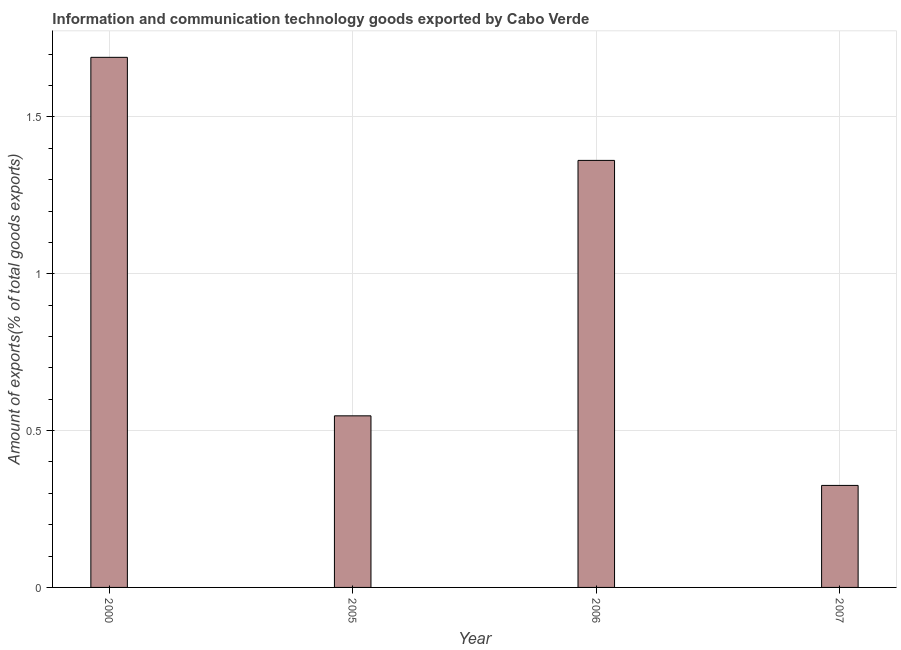What is the title of the graph?
Ensure brevity in your answer.  Information and communication technology goods exported by Cabo Verde. What is the label or title of the Y-axis?
Keep it short and to the point. Amount of exports(% of total goods exports). What is the amount of ict goods exports in 2005?
Your response must be concise. 0.55. Across all years, what is the maximum amount of ict goods exports?
Make the answer very short. 1.69. Across all years, what is the minimum amount of ict goods exports?
Your answer should be compact. 0.33. In which year was the amount of ict goods exports maximum?
Ensure brevity in your answer.  2000. In which year was the amount of ict goods exports minimum?
Make the answer very short. 2007. What is the sum of the amount of ict goods exports?
Provide a short and direct response. 3.92. What is the difference between the amount of ict goods exports in 2005 and 2007?
Keep it short and to the point. 0.22. What is the average amount of ict goods exports per year?
Your answer should be very brief. 0.98. What is the median amount of ict goods exports?
Provide a short and direct response. 0.95. In how many years, is the amount of ict goods exports greater than 1.2 %?
Provide a succinct answer. 2. Do a majority of the years between 2006 and 2007 (inclusive) have amount of ict goods exports greater than 0.9 %?
Provide a succinct answer. No. What is the ratio of the amount of ict goods exports in 2000 to that in 2006?
Offer a terse response. 1.24. What is the difference between the highest and the second highest amount of ict goods exports?
Provide a short and direct response. 0.33. Is the sum of the amount of ict goods exports in 2000 and 2005 greater than the maximum amount of ict goods exports across all years?
Provide a succinct answer. Yes. What is the difference between the highest and the lowest amount of ict goods exports?
Your response must be concise. 1.36. Are all the bars in the graph horizontal?
Provide a short and direct response. No. What is the difference between two consecutive major ticks on the Y-axis?
Provide a short and direct response. 0.5. Are the values on the major ticks of Y-axis written in scientific E-notation?
Provide a short and direct response. No. What is the Amount of exports(% of total goods exports) in 2000?
Offer a very short reply. 1.69. What is the Amount of exports(% of total goods exports) in 2005?
Offer a terse response. 0.55. What is the Amount of exports(% of total goods exports) in 2006?
Offer a terse response. 1.36. What is the Amount of exports(% of total goods exports) of 2007?
Make the answer very short. 0.33. What is the difference between the Amount of exports(% of total goods exports) in 2000 and 2005?
Provide a succinct answer. 1.14. What is the difference between the Amount of exports(% of total goods exports) in 2000 and 2006?
Provide a succinct answer. 0.33. What is the difference between the Amount of exports(% of total goods exports) in 2000 and 2007?
Provide a short and direct response. 1.36. What is the difference between the Amount of exports(% of total goods exports) in 2005 and 2006?
Provide a short and direct response. -0.81. What is the difference between the Amount of exports(% of total goods exports) in 2005 and 2007?
Keep it short and to the point. 0.22. What is the difference between the Amount of exports(% of total goods exports) in 2006 and 2007?
Your response must be concise. 1.04. What is the ratio of the Amount of exports(% of total goods exports) in 2000 to that in 2005?
Provide a succinct answer. 3.09. What is the ratio of the Amount of exports(% of total goods exports) in 2000 to that in 2006?
Give a very brief answer. 1.24. What is the ratio of the Amount of exports(% of total goods exports) in 2000 to that in 2007?
Make the answer very short. 5.2. What is the ratio of the Amount of exports(% of total goods exports) in 2005 to that in 2006?
Offer a very short reply. 0.4. What is the ratio of the Amount of exports(% of total goods exports) in 2005 to that in 2007?
Your answer should be compact. 1.68. What is the ratio of the Amount of exports(% of total goods exports) in 2006 to that in 2007?
Offer a terse response. 4.19. 